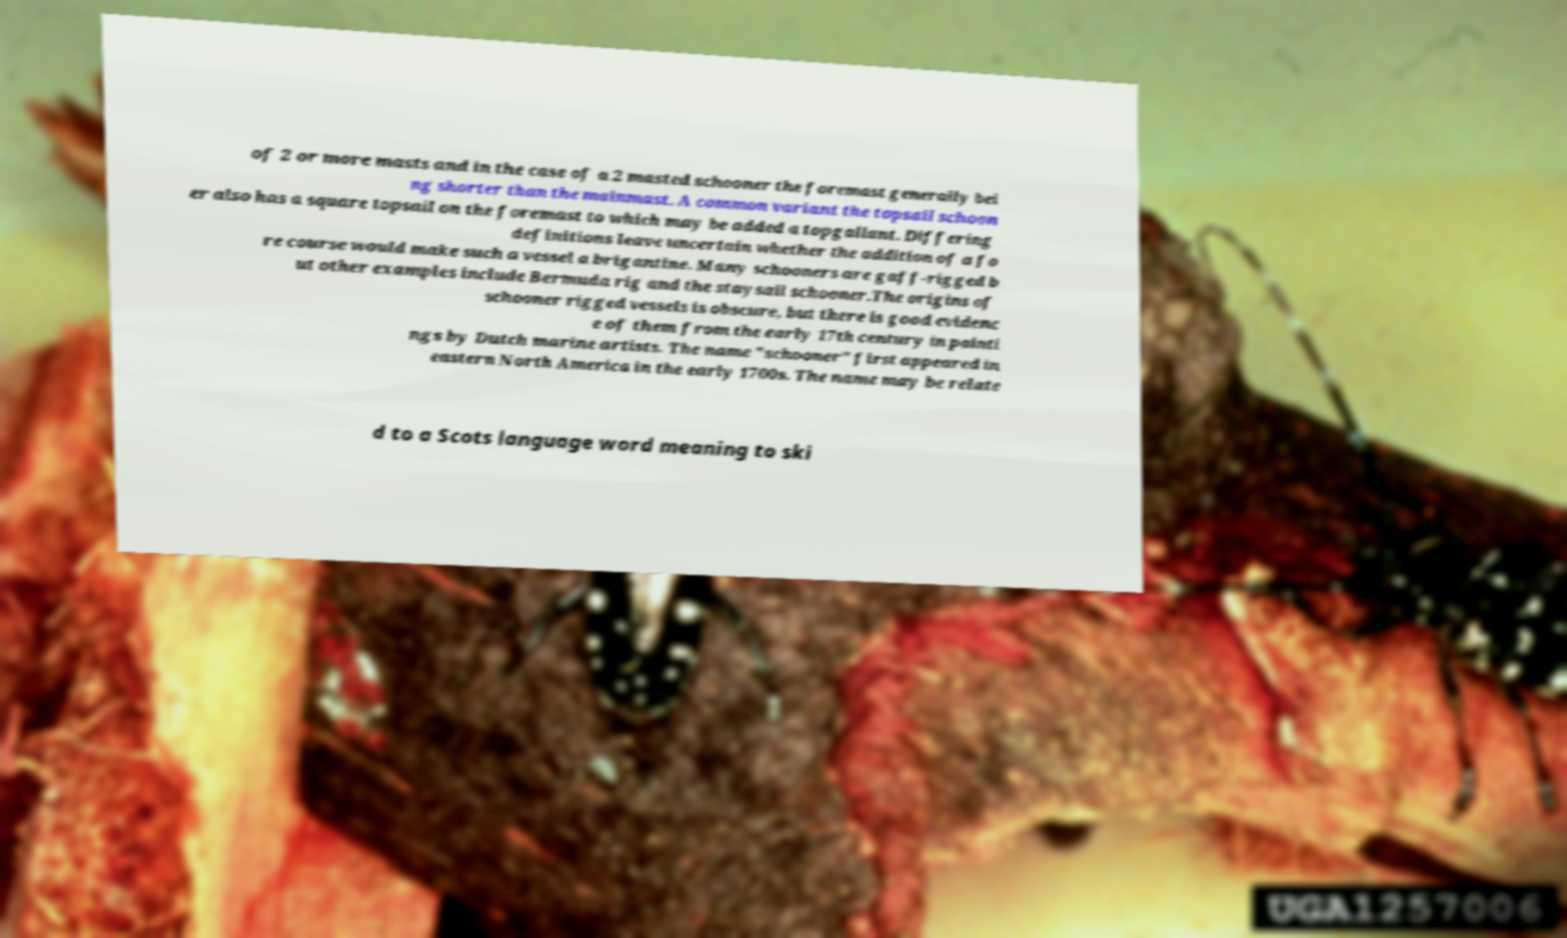What messages or text are displayed in this image? I need them in a readable, typed format. of 2 or more masts and in the case of a 2 masted schooner the foremast generally bei ng shorter than the mainmast. A common variant the topsail schoon er also has a square topsail on the foremast to which may be added a topgallant. Differing definitions leave uncertain whether the addition of a fo re course would make such a vessel a brigantine. Many schooners are gaff-rigged b ut other examples include Bermuda rig and the staysail schooner.The origins of schooner rigged vessels is obscure, but there is good evidenc e of them from the early 17th century in painti ngs by Dutch marine artists. The name "schooner" first appeared in eastern North America in the early 1700s. The name may be relate d to a Scots language word meaning to ski 